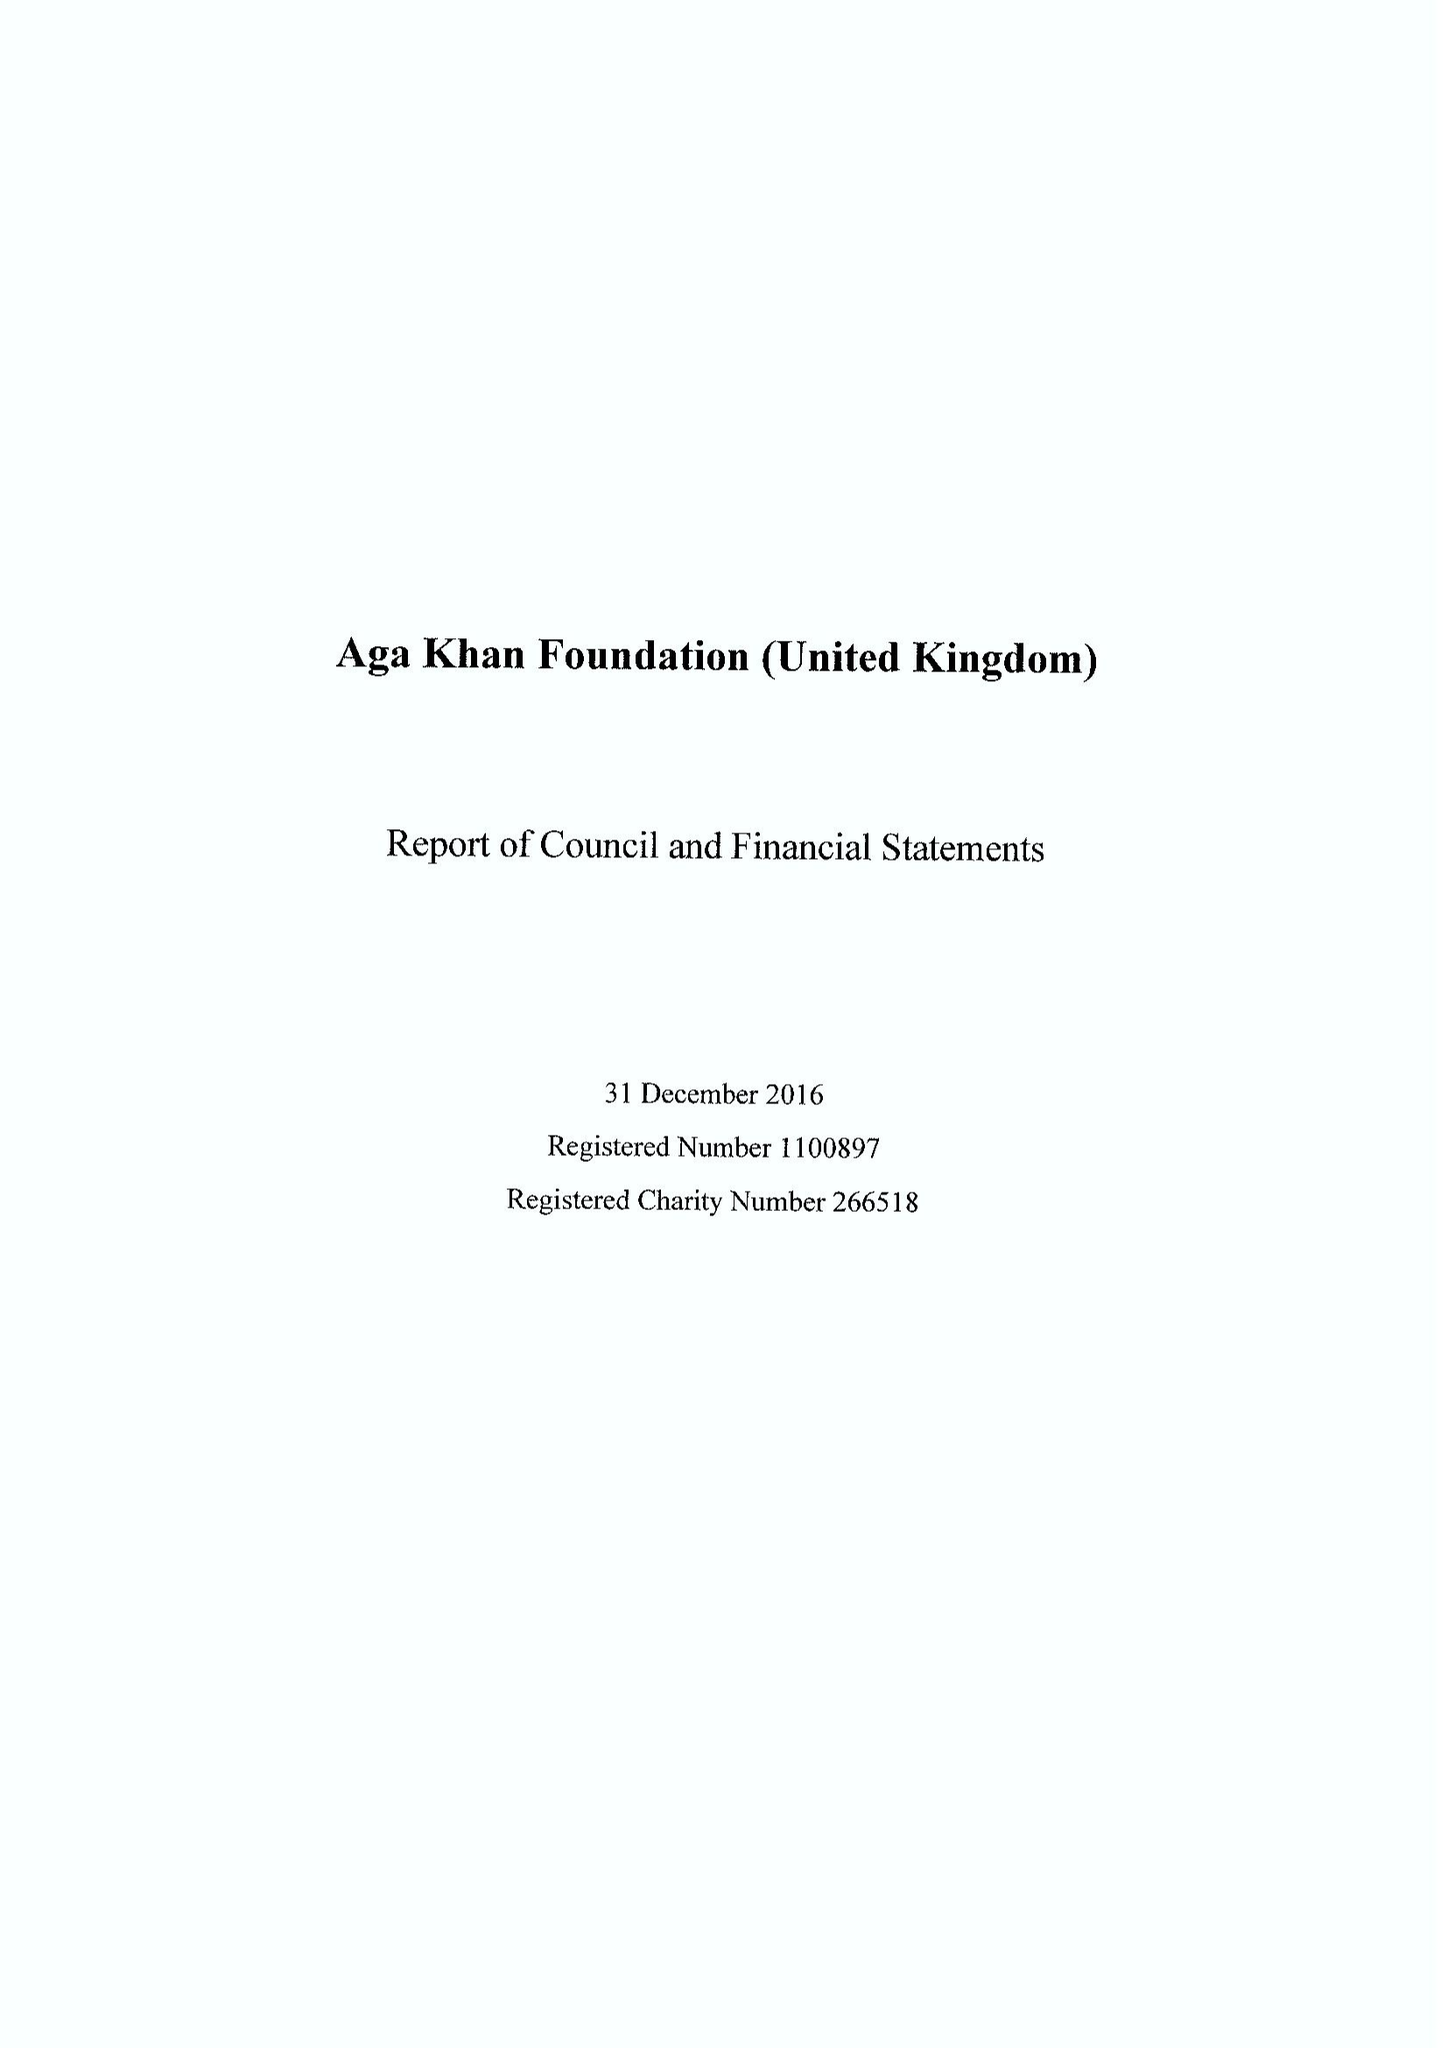What is the value for the address__street_line?
Answer the question using a single word or phrase. 10 HANDYSIDE STREET 